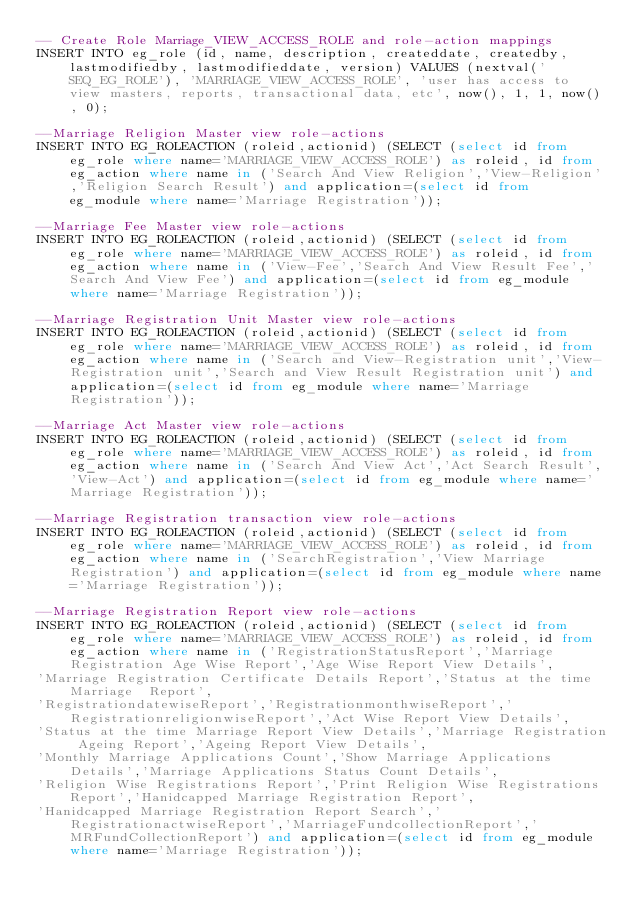<code> <loc_0><loc_0><loc_500><loc_500><_SQL_>-- Create Role Marriage_VIEW_ACCESS_ROLE and role-action mappings
INSERT INTO eg_role (id, name, description, createddate, createdby, lastmodifiedby, lastmodifieddate, version) VALUES (nextval('SEQ_EG_ROLE'), 'MARRIAGE_VIEW_ACCESS_ROLE', 'user has access to view masters, reports, transactional data, etc', now(), 1, 1, now(), 0);

--Marriage Religion Master view role-actions
INSERT INTO EG_ROLEACTION (roleid,actionid) (SELECT (select id from eg_role where name='MARRIAGE_VIEW_ACCESS_ROLE') as roleid, id from eg_action where name in ('Search And View Religion','View-Religion','Religion Search Result') and application=(select id from eg_module where name='Marriage Registration'));

--Marriage Fee Master view role-actions
INSERT INTO EG_ROLEACTION (roleid,actionid) (SELECT (select id from eg_role where name='MARRIAGE_VIEW_ACCESS_ROLE') as roleid, id from eg_action where name in ('View-Fee','Search And View Result Fee','Search And View Fee') and application=(select id from eg_module where name='Marriage Registration'));

--Marriage Registration Unit Master view role-actions
INSERT INTO EG_ROLEACTION (roleid,actionid) (SELECT (select id from eg_role where name='MARRIAGE_VIEW_ACCESS_ROLE') as roleid, id from eg_action where name in ('Search and View-Registration unit','View-Registration unit','Search and View Result Registration unit') and application=(select id from eg_module where name='Marriage Registration'));

--Marriage Act Master view role-actions
INSERT INTO EG_ROLEACTION (roleid,actionid) (SELECT (select id from eg_role where name='MARRIAGE_VIEW_ACCESS_ROLE') as roleid, id from eg_action where name in ('Search And View Act','Act Search Result','View-Act') and application=(select id from eg_module where name='Marriage Registration'));

--Marriage Registration transaction view role-actions
INSERT INTO EG_ROLEACTION (roleid,actionid) (SELECT (select id from eg_role where name='MARRIAGE_VIEW_ACCESS_ROLE') as roleid, id from eg_action where name in ('SearchRegistration','View Marriage Registration') and application=(select id from eg_module where name='Marriage Registration'));

--Marriage Registration Report view role-actions
INSERT INTO EG_ROLEACTION (roleid,actionid) (SELECT (select id from eg_role where name='MARRIAGE_VIEW_ACCESS_ROLE') as roleid, id from eg_action where name in ('RegistrationStatusReport','Marriage Registration Age Wise Report','Age Wise Report View Details',
'Marriage Registration Certificate Details Report','Status at the time Marriage  Report',
'RegistrationdatewiseReport','RegistrationmonthwiseReport','RegistrationreligionwiseReport','Act Wise Report View Details',
'Status at the time Marriage Report View Details','Marriage Registration Ageing Report','Ageing Report View Details',
'Monthly Marriage Applications Count','Show Marriage Applications Details','Marriage Applications Status Count Details',
'Religion Wise Registrations Report','Print Religion Wise Registrations Report','Hanidcapped Marriage Registration Report',
'Hanidcapped Marriage Registration Report Search','RegistrationactwiseReport','MarriageFundcollectionReport','MRFundCollectionReport') and application=(select id from eg_module where name='Marriage Registration'));</code> 